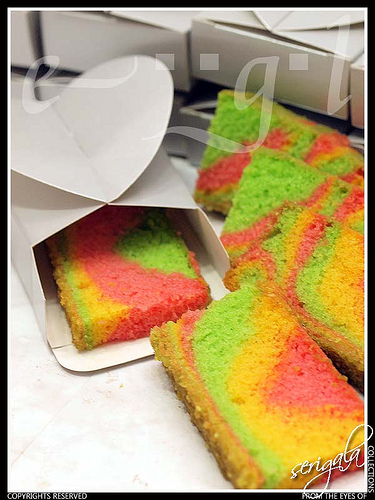<image>
Is there a cake in front of the box? No. The cake is not in front of the box. The spatial positioning shows a different relationship between these objects. Where is the lid in relation to the slice? Is it to the left of the slice? Yes. From this viewpoint, the lid is positioned to the left side relative to the slice. 